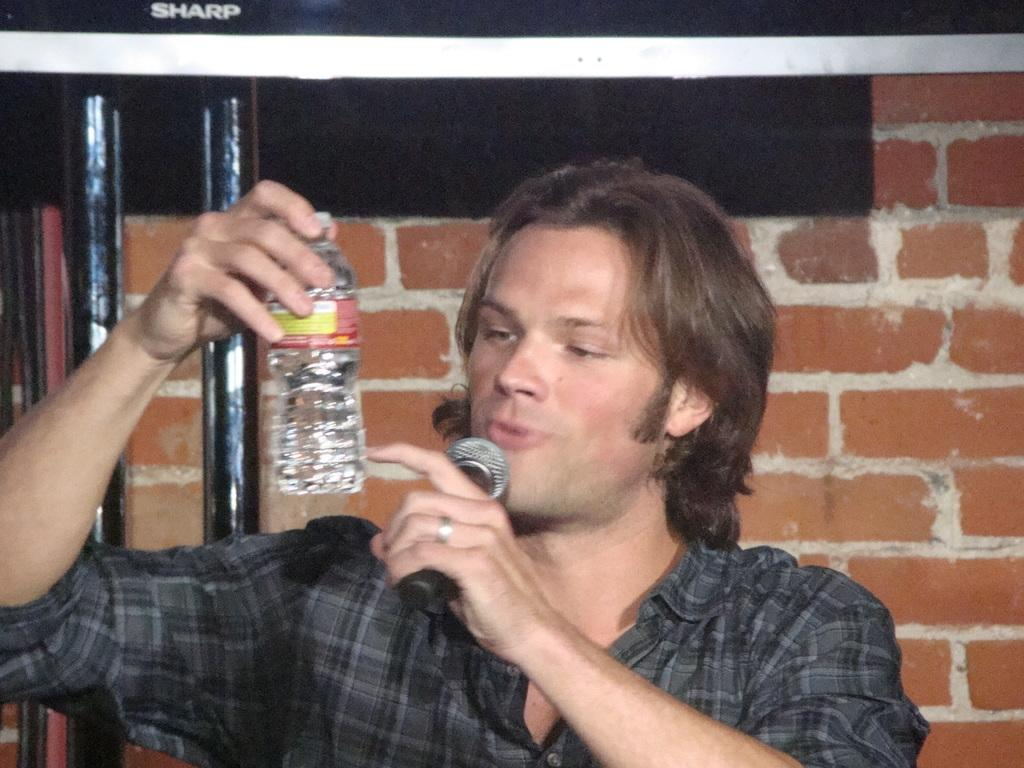What is the man in the image holding in one hand? The man is holding a microphone in one hand. What is the man in the image holding in the other hand? The man is holding a bottle in the other hand. What can be seen in the background of the image? There is a wall in the background of the image. What type of shoe can be seen on the wall in the image? There is no shoe present on the wall in the image. What type of horn is the man playing in the image? The man is not playing any horn in the image; he is holding a microphone and a bottle. 